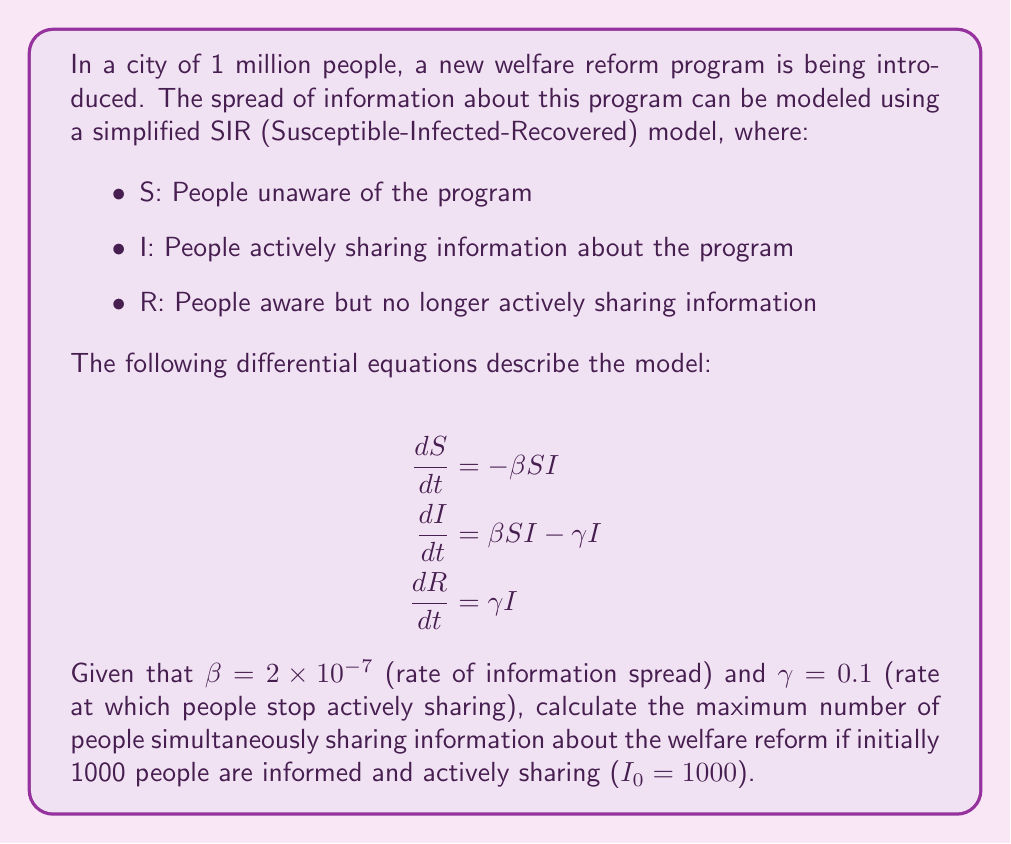Could you help me with this problem? To solve this problem, we need to find the peak of the I(t) curve. This occurs when dI/dt = 0. Let's approach this step-by-step:

1) At the peak, dI/dt = 0:
   $$0 = \beta SI - \gamma I$$

2) Divide both sides by I:
   $$0 = \beta S - \gamma$$

3) Solve for S:
   $$S = \frac{\gamma}{\beta}$$

4) Substitute the given values:
   $$S = \frac{0.1}{2 \times 10^{-7}} = 500,000$$

5) Now, we can use the conservation of population:
   $$N = S + I + R = 1,000,000$$

6) At t = 0, R₀ = 0, S₀ = 999,000, and I₀ = 1000

7) When I is at its peak, we can find R:
   $$R = N - S - I = 1,000,000 - 500,000 - I = 500,000 - I$$

8) We can find I using the conservation of population and the fact that the total number of people who have been informed (I + R) is equal to the initial susceptible population minus the current susceptible population:
   $$I + R = S₀ - S = 999,000 - 500,000 = 499,000$$

9) Substituting the expression for R:
   $$I + (500,000 - I) = 499,000$$
   $$500,000 = 499,000$$
   $$I = 499,000 - 500,000 + I$$
   $$I = 249,500$$

Therefore, the maximum number of people simultaneously sharing information about the welfare reform is approximately 249,500.
Answer: 249,500 people 